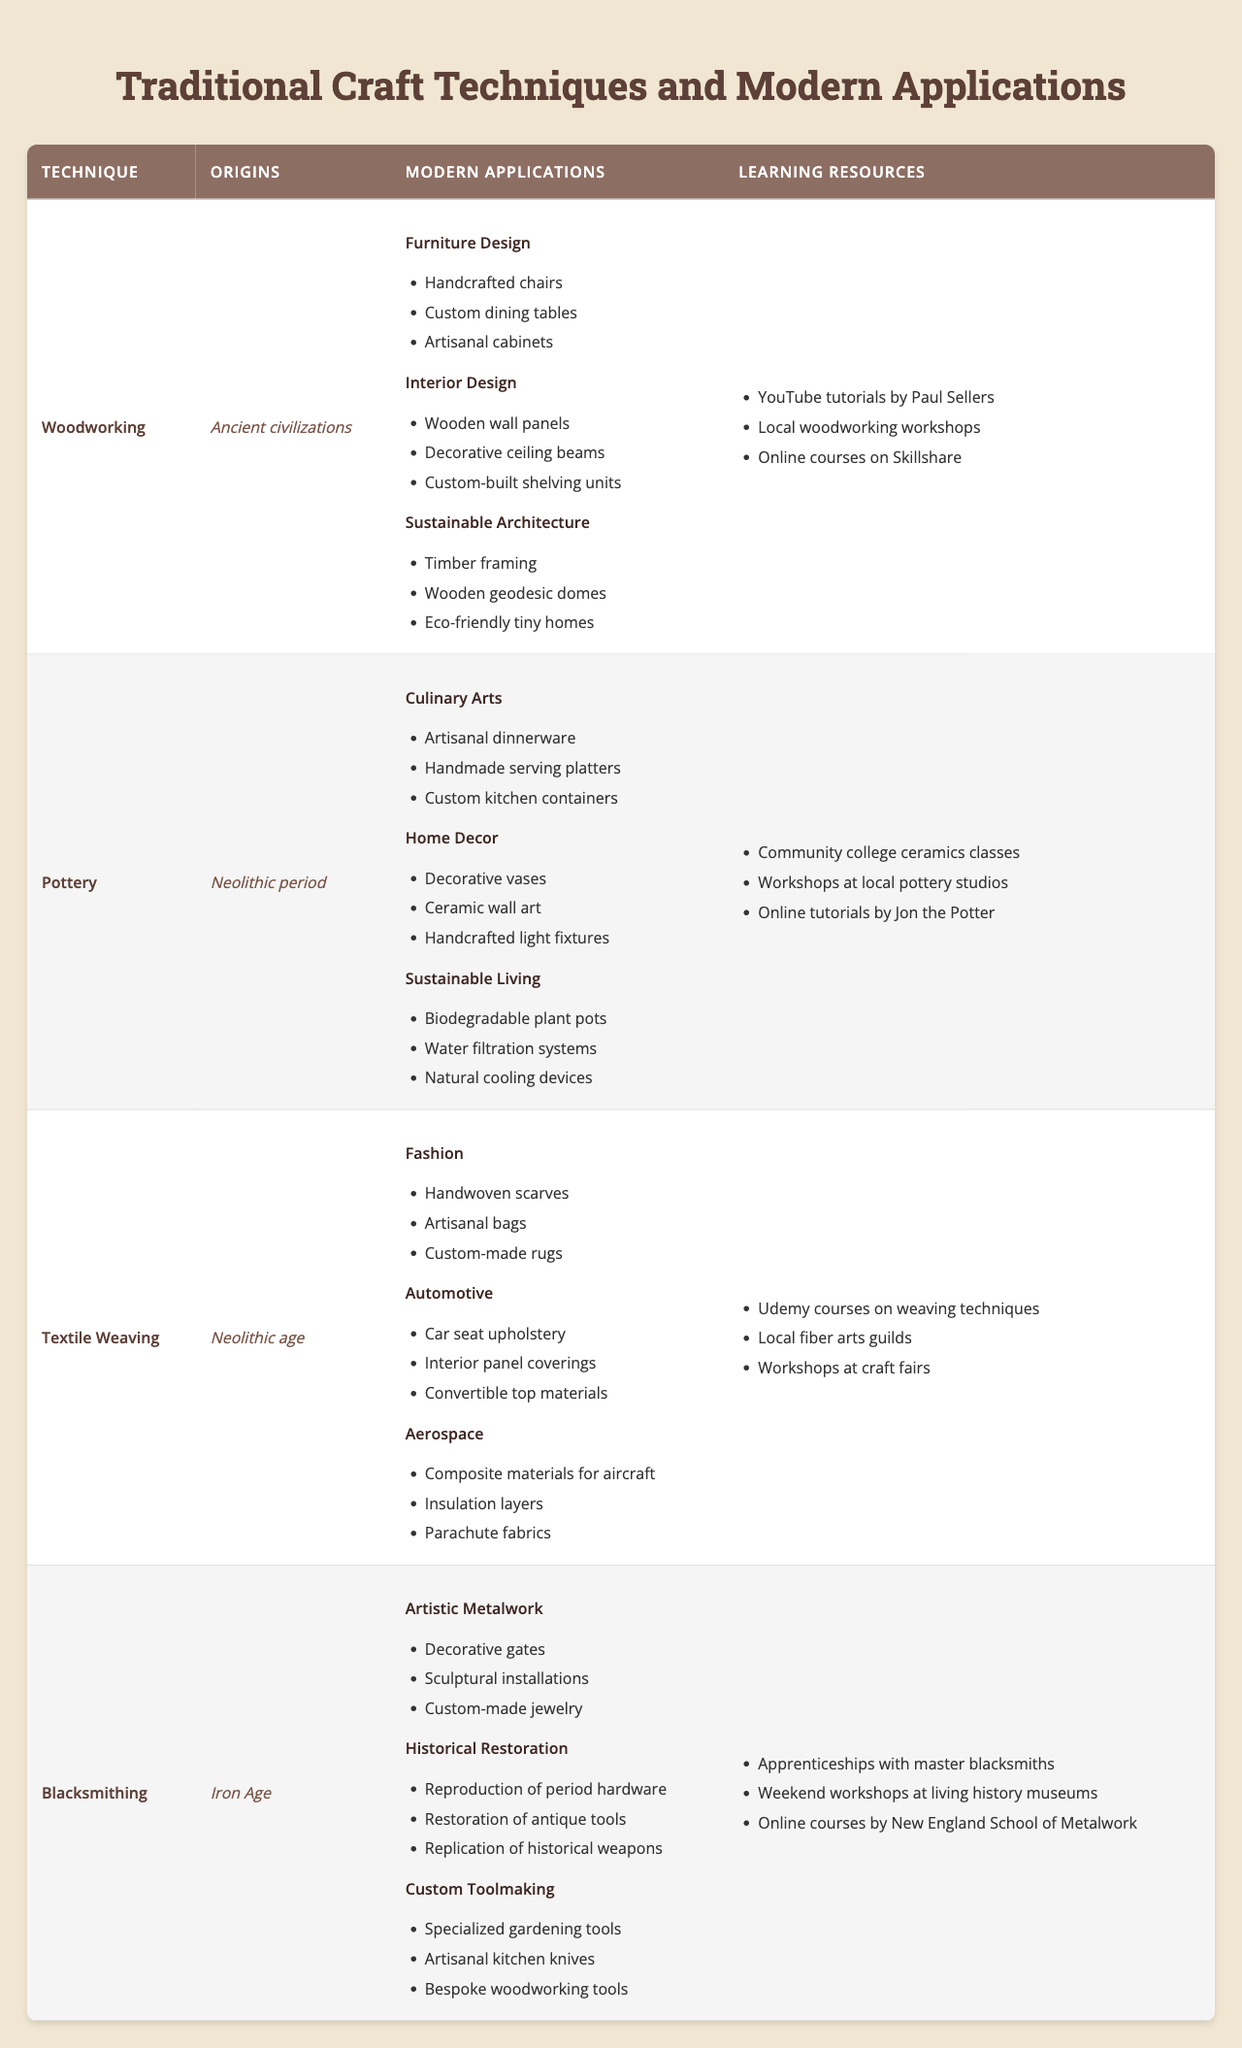What is the origin of blacksmithing? The table states that blacksmithing originated in the Iron Age.
Answer: Iron Age Which industry applies woodworking techniques for creating custom-built shelving units? The table indicates that "Custom-built shelving units" are used in the Interior Design industry under woodworking.
Answer: Interior Design List two examples of modern applications for pottery in the culinary arts. The modern applications listed in the table for the culinary arts include "Artisanal dinnerware" and "Handmade serving platters."
Answer: Artisanal dinnerware, Handmade serving platters How many different industries are mentioned under textile weaving? The table lists three industries under textile weaving: Fashion, Automotive, and Aerospace. Therefore, the total is three.
Answer: 3 Is there a modern application for blacksmithing in custom toolmaking? Yes, the table confirms that there are applications for blacksmithing in the custom toolmaking industry.
Answer: Yes What are two learning resources for woodworking? The table lists learning resources for woodworking, which include "YouTube tutorials by Paul Sellers" and "Local woodworking workshops."
Answer: YouTube tutorials by Paul Sellers, Local woodworking workshops Identify the technique with the most modern applications listed. Woodworking features modern applications in Furniture Design, Interior Design, and Sustainable Architecture, totaling three applications. The same is true for pottery and textile weaving, but blacksmithing has fewer with only three applications across industries.
Answer: Woodworking Which technique has the same number of learning resources as modern applications? Pottery has three modern applications (Culinary Arts, Home Decor, Sustainable Living) and also has three learning resources listed in the table.
Answer: Pottery What types of products are included in sustainable living for pottery? The table provides examples such as "Biodegradable plant pots," "Water filtration systems," and "Natural cooling devices" under sustainable living for pottery.
Answer: Biodegradable plant pots, Water filtration systems, Natural cooling devices How does the number of learning resources for blacksmithing compare to that of woodworking? The table shows that blacksmithing has three learning resources, whereas woodworking has three as well. They are equal in number.
Answer: Equal Which traditional craft technique is linked to the automotive industry? The technique linked to the automotive industry, as per the table, is Textile Weaving.
Answer: Textile Weaving 